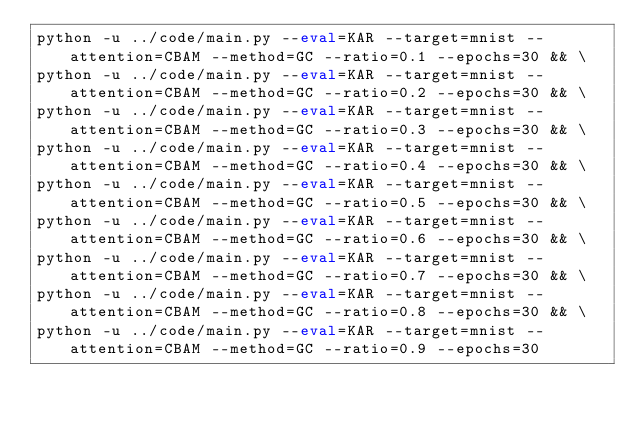Convert code to text. <code><loc_0><loc_0><loc_500><loc_500><_Bash_>python -u ../code/main.py --eval=KAR --target=mnist --attention=CBAM --method=GC --ratio=0.1 --epochs=30 && \
python -u ../code/main.py --eval=KAR --target=mnist --attention=CBAM --method=GC --ratio=0.2 --epochs=30 && \
python -u ../code/main.py --eval=KAR --target=mnist --attention=CBAM --method=GC --ratio=0.3 --epochs=30 && \
python -u ../code/main.py --eval=KAR --target=mnist --attention=CBAM --method=GC --ratio=0.4 --epochs=30 && \
python -u ../code/main.py --eval=KAR --target=mnist --attention=CBAM --method=GC --ratio=0.5 --epochs=30 && \
python -u ../code/main.py --eval=KAR --target=mnist --attention=CBAM --method=GC --ratio=0.6 --epochs=30 && \
python -u ../code/main.py --eval=KAR --target=mnist --attention=CBAM --method=GC --ratio=0.7 --epochs=30 && \
python -u ../code/main.py --eval=KAR --target=mnist --attention=CBAM --method=GC --ratio=0.8 --epochs=30 && \
python -u ../code/main.py --eval=KAR --target=mnist --attention=CBAM --method=GC --ratio=0.9 --epochs=30</code> 